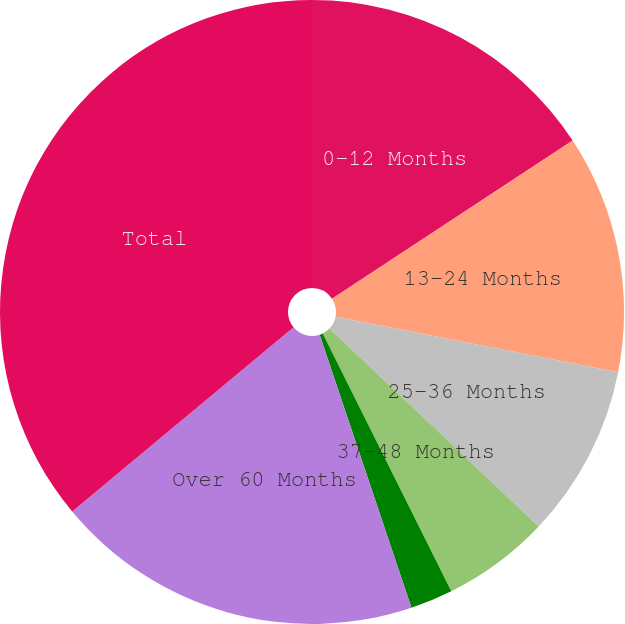<chart> <loc_0><loc_0><loc_500><loc_500><pie_chart><fcel>0-12 Months<fcel>13-24 Months<fcel>25-36 Months<fcel>37-48 Months<fcel>49-60 Months<fcel>Over 60 Months<fcel>Total<nl><fcel>15.74%<fcel>12.35%<fcel>8.97%<fcel>5.58%<fcel>2.2%<fcel>19.12%<fcel>36.05%<nl></chart> 